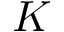Convert formula to latex. <formula><loc_0><loc_0><loc_500><loc_500>K</formula> 